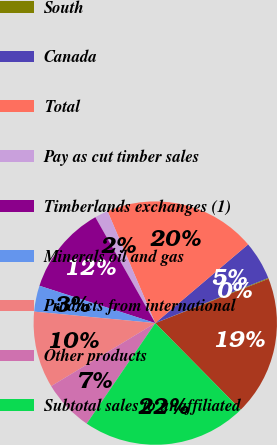Convert chart. <chart><loc_0><loc_0><loc_500><loc_500><pie_chart><fcel>West<fcel>South<fcel>Canada<fcel>Total<fcel>Pay as cut timber sales<fcel>Timberlands exchanges (1)<fcel>Minerals oil and gas<fcel>Products from international<fcel>Other products<fcel>Subtotal sales to unaffiliated<nl><fcel>18.55%<fcel>0.11%<fcel>5.14%<fcel>20.23%<fcel>1.78%<fcel>11.84%<fcel>3.46%<fcel>10.17%<fcel>6.81%<fcel>21.91%<nl></chart> 